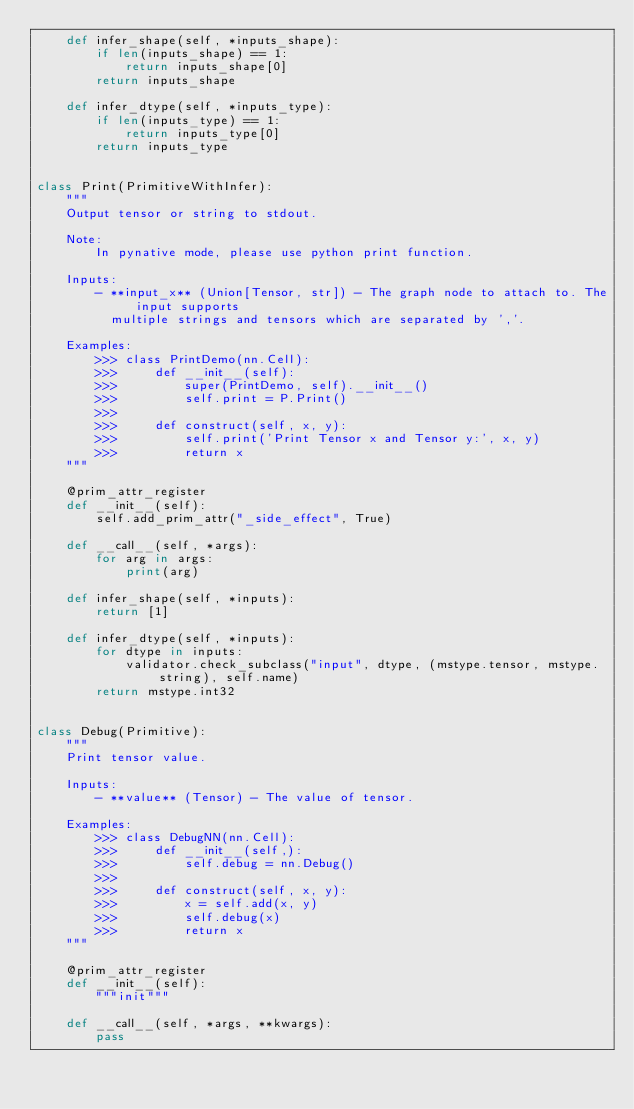Convert code to text. <code><loc_0><loc_0><loc_500><loc_500><_Python_>    def infer_shape(self, *inputs_shape):
        if len(inputs_shape) == 1:
            return inputs_shape[0]
        return inputs_shape

    def infer_dtype(self, *inputs_type):
        if len(inputs_type) == 1:
            return inputs_type[0]
        return inputs_type


class Print(PrimitiveWithInfer):
    """
    Output tensor or string to stdout.

    Note:
        In pynative mode, please use python print function.

    Inputs:
        - **input_x** (Union[Tensor, str]) - The graph node to attach to. The input supports
          multiple strings and tensors which are separated by ','.

    Examples:
        >>> class PrintDemo(nn.Cell):
        >>>     def __init__(self):
        >>>         super(PrintDemo, self).__init__()
        >>>         self.print = P.Print()
        >>>
        >>>     def construct(self, x, y):
        >>>         self.print('Print Tensor x and Tensor y:', x, y)
        >>>         return x
    """

    @prim_attr_register
    def __init__(self):
        self.add_prim_attr("_side_effect", True)

    def __call__(self, *args):
        for arg in args:
            print(arg)

    def infer_shape(self, *inputs):
        return [1]

    def infer_dtype(self, *inputs):
        for dtype in inputs:
            validator.check_subclass("input", dtype, (mstype.tensor, mstype.string), self.name)
        return mstype.int32


class Debug(Primitive):
    """
    Print tensor value.

    Inputs:
        - **value** (Tensor) - The value of tensor.

    Examples:
        >>> class DebugNN(nn.Cell):
        >>>     def __init__(self,):
        >>>         self.debug = nn.Debug()
        >>>
        >>>     def construct(self, x, y):
        >>>         x = self.add(x, y)
        >>>         self.debug(x)
        >>>         return x
    """

    @prim_attr_register
    def __init__(self):
        """init"""

    def __call__(self, *args, **kwargs):
        pass
</code> 